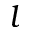<formula> <loc_0><loc_0><loc_500><loc_500>{ l }</formula> 